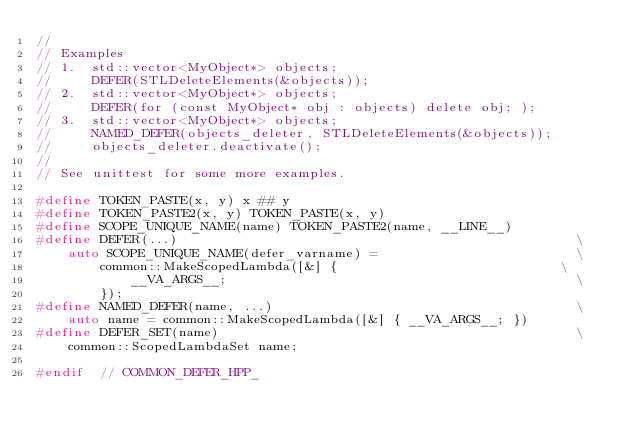Convert code to text. <code><loc_0><loc_0><loc_500><loc_500><_C_>//
// Examples
// 1.  std::vector<MyObject*> objects;
//     DEFER(STLDeleteElements(&objects));
// 2.  std::vector<MyObject*> objects;
//     DEFER(for (const MyObject* obj : objects) delete obj; );
// 3.  std::vector<MyObject*> objects;
//     NAMED_DEFER(objects_deleter, STLDeleteElements(&objects));
//     objects_deleter.deactivate();
//
// See unittest for some more examples.

#define TOKEN_PASTE(x, y) x ## y
#define TOKEN_PASTE2(x, y) TOKEN_PASTE(x, y)
#define SCOPE_UNIQUE_NAME(name) TOKEN_PASTE2(name, __LINE__)
#define DEFER(...)                                                  \
    auto SCOPE_UNIQUE_NAME(defer_varname) =                         \
        common::MakeScopedLambda([&] {                            \
            __VA_ARGS__;                                            \
        });
#define NAMED_DEFER(name, ...)                                      \
    auto name = common::MakeScopedLambda([&] { __VA_ARGS__; })
#define DEFER_SET(name)                                             \
    common::ScopedLambdaSet name;

#endif  // COMMON_DEFER_HPP_
</code> 